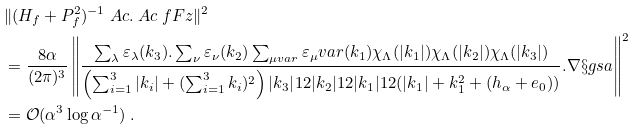Convert formula to latex. <formula><loc_0><loc_0><loc_500><loc_500>& \| ( H _ { f } + P _ { f } ^ { 2 } ) ^ { - 1 } \ A c . \ A c \ f F z \| ^ { 2 } \\ & = \frac { 8 \alpha } { ( 2 \pi ) ^ { 3 } } \left \| \frac { \sum _ { \lambda } \varepsilon _ { \lambda } ( k _ { 3 } ) . \sum _ { \nu } \varepsilon _ { \nu } ( k _ { 2 } ) \sum _ { \mu v a r } \varepsilon _ { \mu } v a r ( k _ { 1 } ) \chi _ { \Lambda } ( | k _ { 1 } | ) \chi _ { \Lambda } ( | k _ { 2 } | ) \chi _ { \Lambda } ( | k _ { 3 } | ) } { \left ( \sum _ { i = 1 } ^ { 3 } | k _ { i } | + ( \sum _ { i = 1 } ^ { 3 } k _ { i } ) ^ { 2 } \right ) | k _ { 3 } | ^ { } { 1 } 2 | k _ { 2 } | ^ { } { 1 } 2 | k _ { 1 } | ^ { } { 1 } 2 ( | k _ { 1 } | + k _ { 1 } ^ { 2 } + ( h _ { \alpha } + e _ { 0 } ) ) } . \nabla \S g s a \right \| ^ { 2 } \\ & = \mathcal { O } ( \alpha ^ { 3 } \log \alpha ^ { - 1 } ) \ .</formula> 